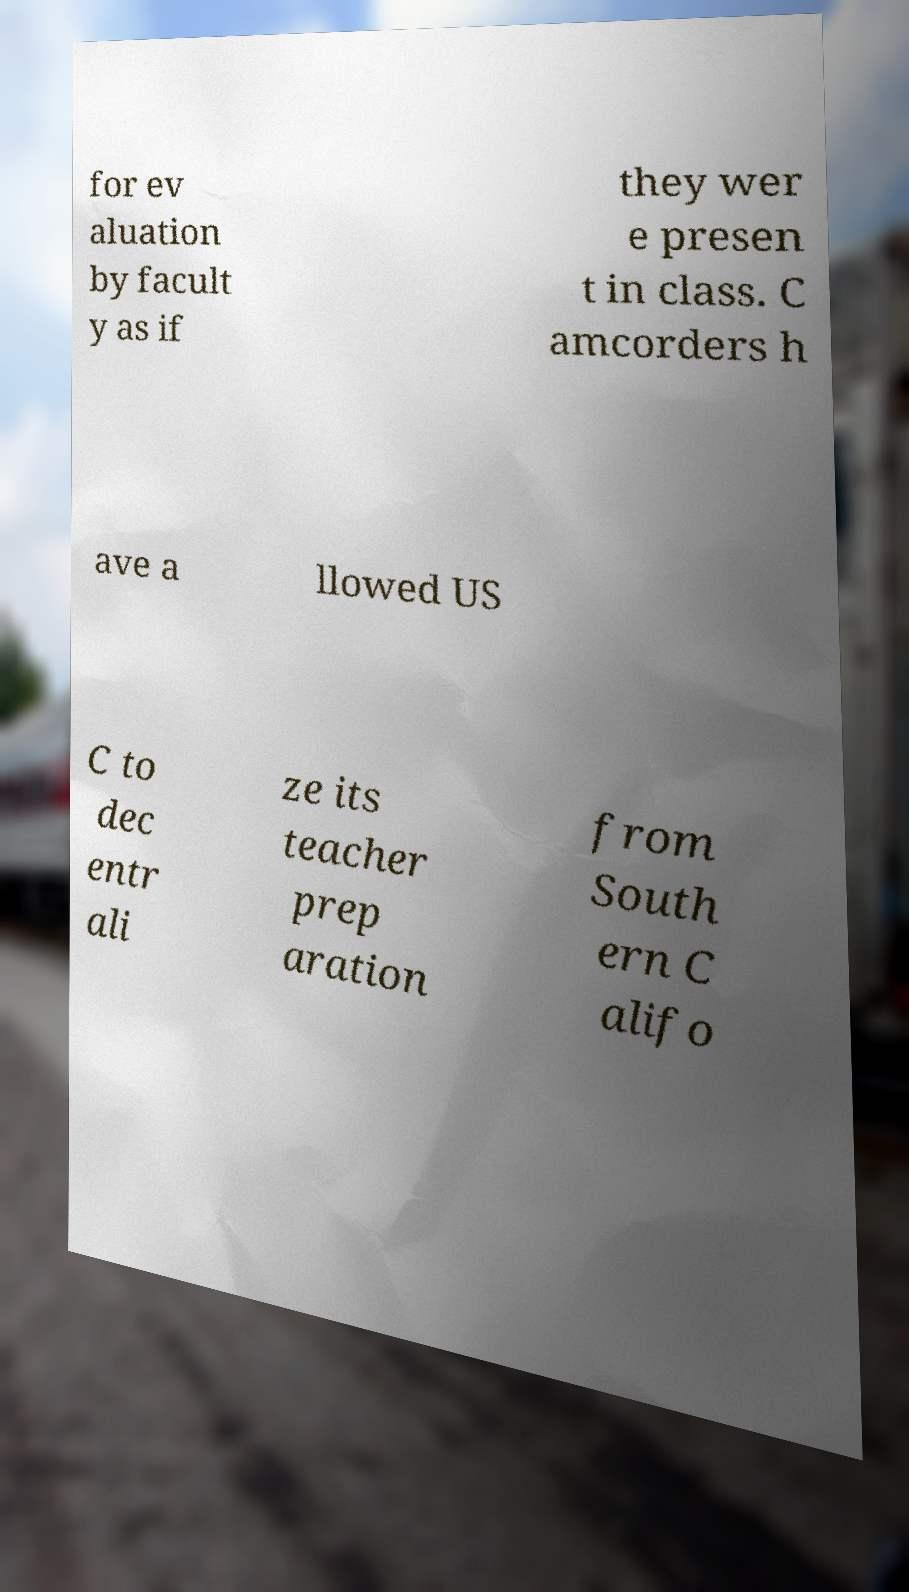Please identify and transcribe the text found in this image. for ev aluation by facult y as if they wer e presen t in class. C amcorders h ave a llowed US C to dec entr ali ze its teacher prep aration from South ern C alifo 